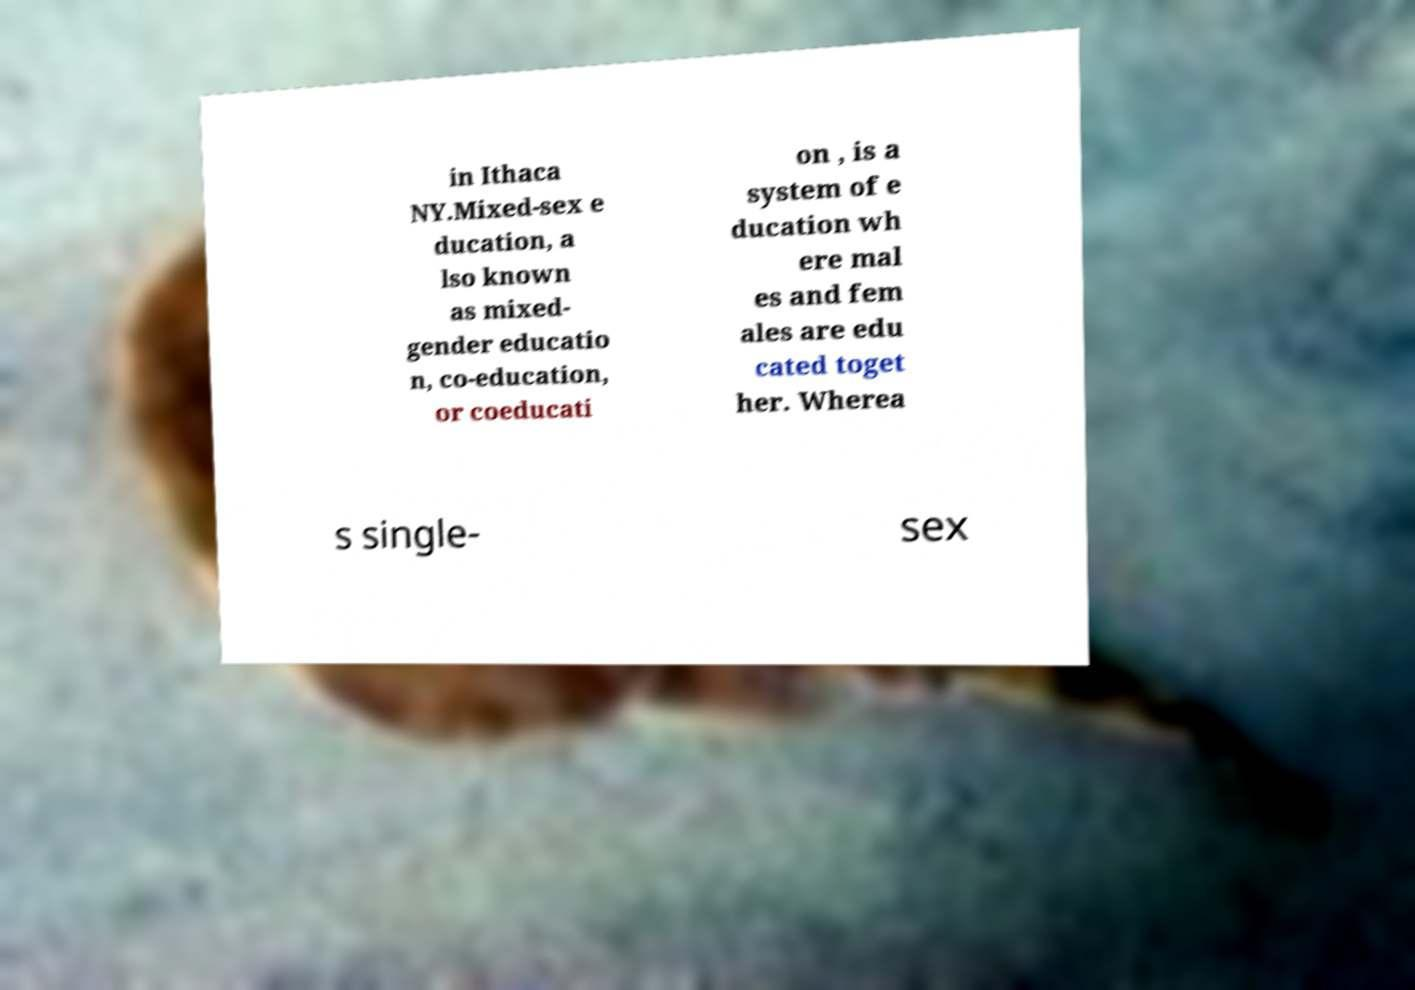Please read and relay the text visible in this image. What does it say? in Ithaca NY.Mixed-sex e ducation, a lso known as mixed- gender educatio n, co-education, or coeducati on , is a system of e ducation wh ere mal es and fem ales are edu cated toget her. Wherea s single- sex 